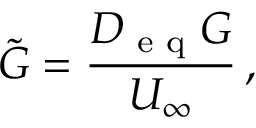Convert formula to latex. <formula><loc_0><loc_0><loc_500><loc_500>\tilde { G } = \frac { D _ { e q } G } { U _ { \infty } } \, ,</formula> 